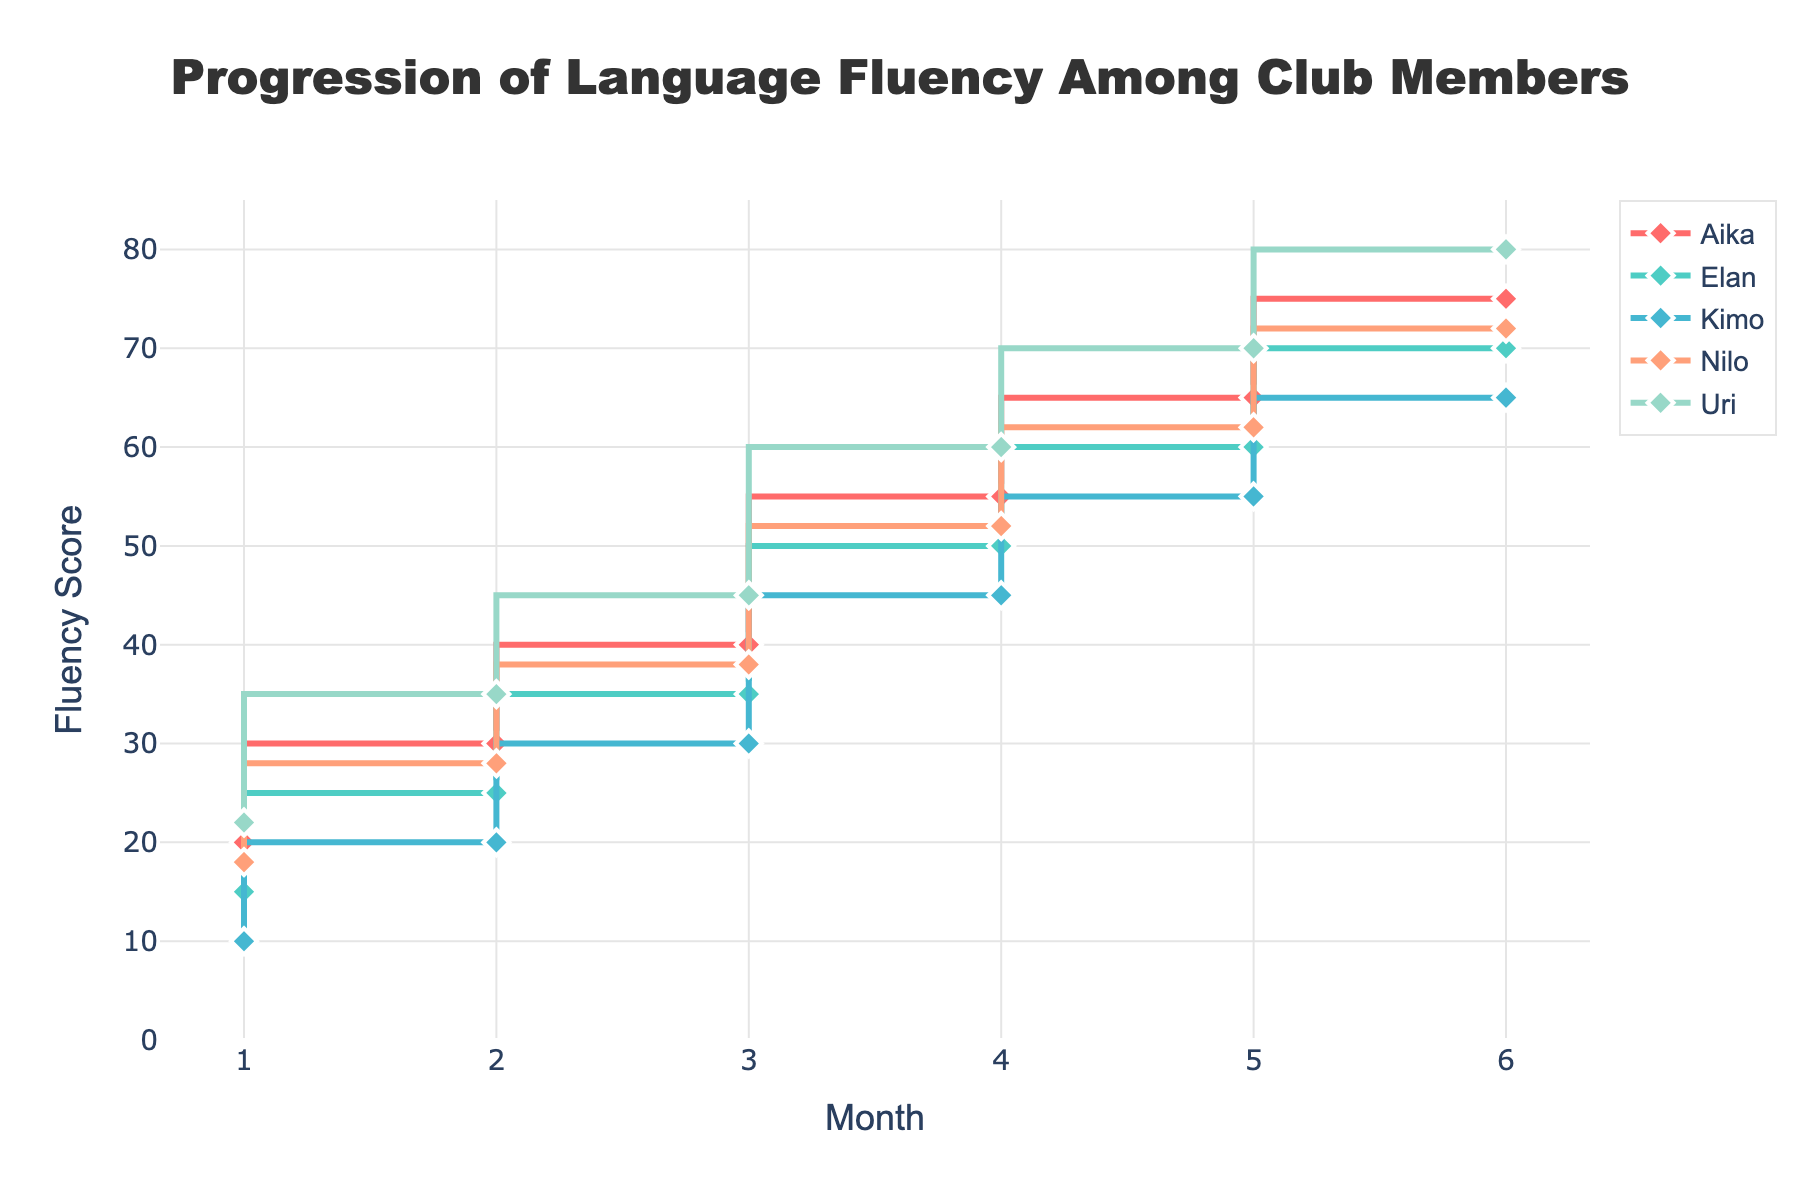What is the title of the figure? The title is displayed prominently at the top center of the figure in large, bold font.
Answer: Progression of Language Fluency Among Club Members How many members are shown in the figure? The legend on the right side of the plot lists the unique members, each represented by a different color.
Answer: Five Which member has the highest fluency score at the final month? By looking at the highest points on the y-axis at month 6, we can see that Uri has the highest fluency score.
Answer: Uri What is Aika's fluency score in the 4th month? Locate the point for Aika at month 4 on the x-axis and trace it up to the y-axis.
Answer: 55 Who showed the greatest improvement in fluency score between months 1 and 6? Compare the final fluency scores at month 6 with the initial scores at month 1 for all members. Uri shows the greatest improvement, from 22 to 80 (an increase of 58 points).
Answer: Uri How does Nilo's fluency score in the 3rd month compare to Kimo's fluency score in the same month? Locate the points for both Nilo and Kimo at month 3 and compare their positions on the y-axis. Nilo's score is 38, and Kimo's score is 30, so Nilo's is higher.
Answer: Nilo's score is higher What is the average fluency score for Elan over the 6 months? Sum up Elan's scores (15 + 25 + 35 + 50 + 60 + 70) and divide by 6.
Answer: 42.5 Compare the fluency scores of all members in the 2nd month. Who has the highest score and who has the lowest? Compare the y-axis values for all members at month 2. Uri has the highest score (35), and Kimo has the lowest (20).
Answer: Uri has the highest, Kimo has the lowest What is the difference in fluency scores between Aika and Elan in the 5th month? Find Aika's and Elan's scores at month 5 (Aika: 65, Elan: 60) and subtract Elan's from Aika's.
Answer: 5 points Which member's fluency score shows the most consistent month-to-month increase? Observe the line shapes for each member and note that Kimo's fluency score increases by a consistent amount (10 points each month).
Answer: Kimo 